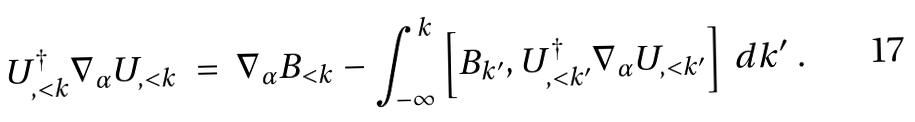<formula> <loc_0><loc_0><loc_500><loc_500>U ^ { \dagger } _ { , < k } \nabla _ { \alpha } U _ { , < k } \ = \ \nabla _ { \alpha } B _ { < k } - \int _ { - \infty } ^ { k } \left [ B _ { k ^ { \prime } } , U ^ { \dagger } _ { , < k ^ { \prime } } \nabla _ { \alpha } U _ { , < k ^ { \prime } } \right ] \, d k ^ { \prime } \ .</formula> 